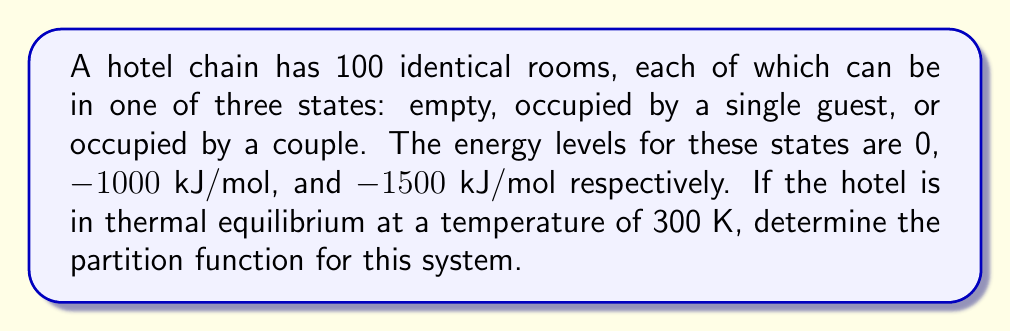Can you answer this question? To solve this problem, we'll follow these steps:

1) First, recall the formula for the partition function:

   $$Z = \sum_i g_i e^{-\beta E_i}$$

   where $g_i$ is the degeneracy of state $i$, $E_i$ is the energy of state $i$, and $\beta = \frac{1}{k_B T}$.

2) In this case, we have three states for each room:
   - Empty: $E_1 = 0$ kJ/mol
   - Single occupancy: $E_2 = -1000$ kJ/mol
   - Double occupancy: $E_3 = -1500$ kJ/mol

3) Calculate $\beta$:
   $$\beta = \frac{1}{k_B T} = \frac{1}{(8.314 \times 10^{-3} \text{ kJ/(mol·K)})(300 \text{ K})} = 0.4011 \text{ mol/kJ}$$

4) Now, let's calculate the partition function for a single room:

   $$z = e^{-\beta E_1} + e^{-\beta E_2} + e^{-\beta E_3}$$
   $$z = e^{0} + e^{0.4011 \times 1000} + e^{0.4011 \times 1500}$$
   $$z = 1 + e^{401.1} + e^{601.65}$$

5) Since there are 100 identical and independent rooms, the total partition function is:

   $$Z = z^{100}$$

6) Substituting the values:

   $$Z = (1 + e^{401.1} + e^{601.65})^{100}$$

This is the partition function for the entire hotel system.
Answer: $Z = (1 + e^{401.1} + e^{601.65})^{100}$ 